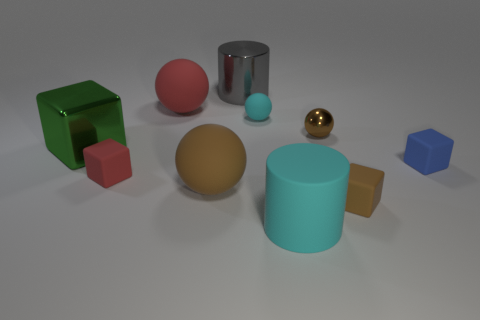Subtract 1 blocks. How many blocks are left? 3 Subtract all balls. How many objects are left? 6 Subtract 0 purple cylinders. How many objects are left? 10 Subtract all small rubber blocks. Subtract all blue blocks. How many objects are left? 6 Add 2 small matte things. How many small matte things are left? 6 Add 5 tiny blue blocks. How many tiny blue blocks exist? 6 